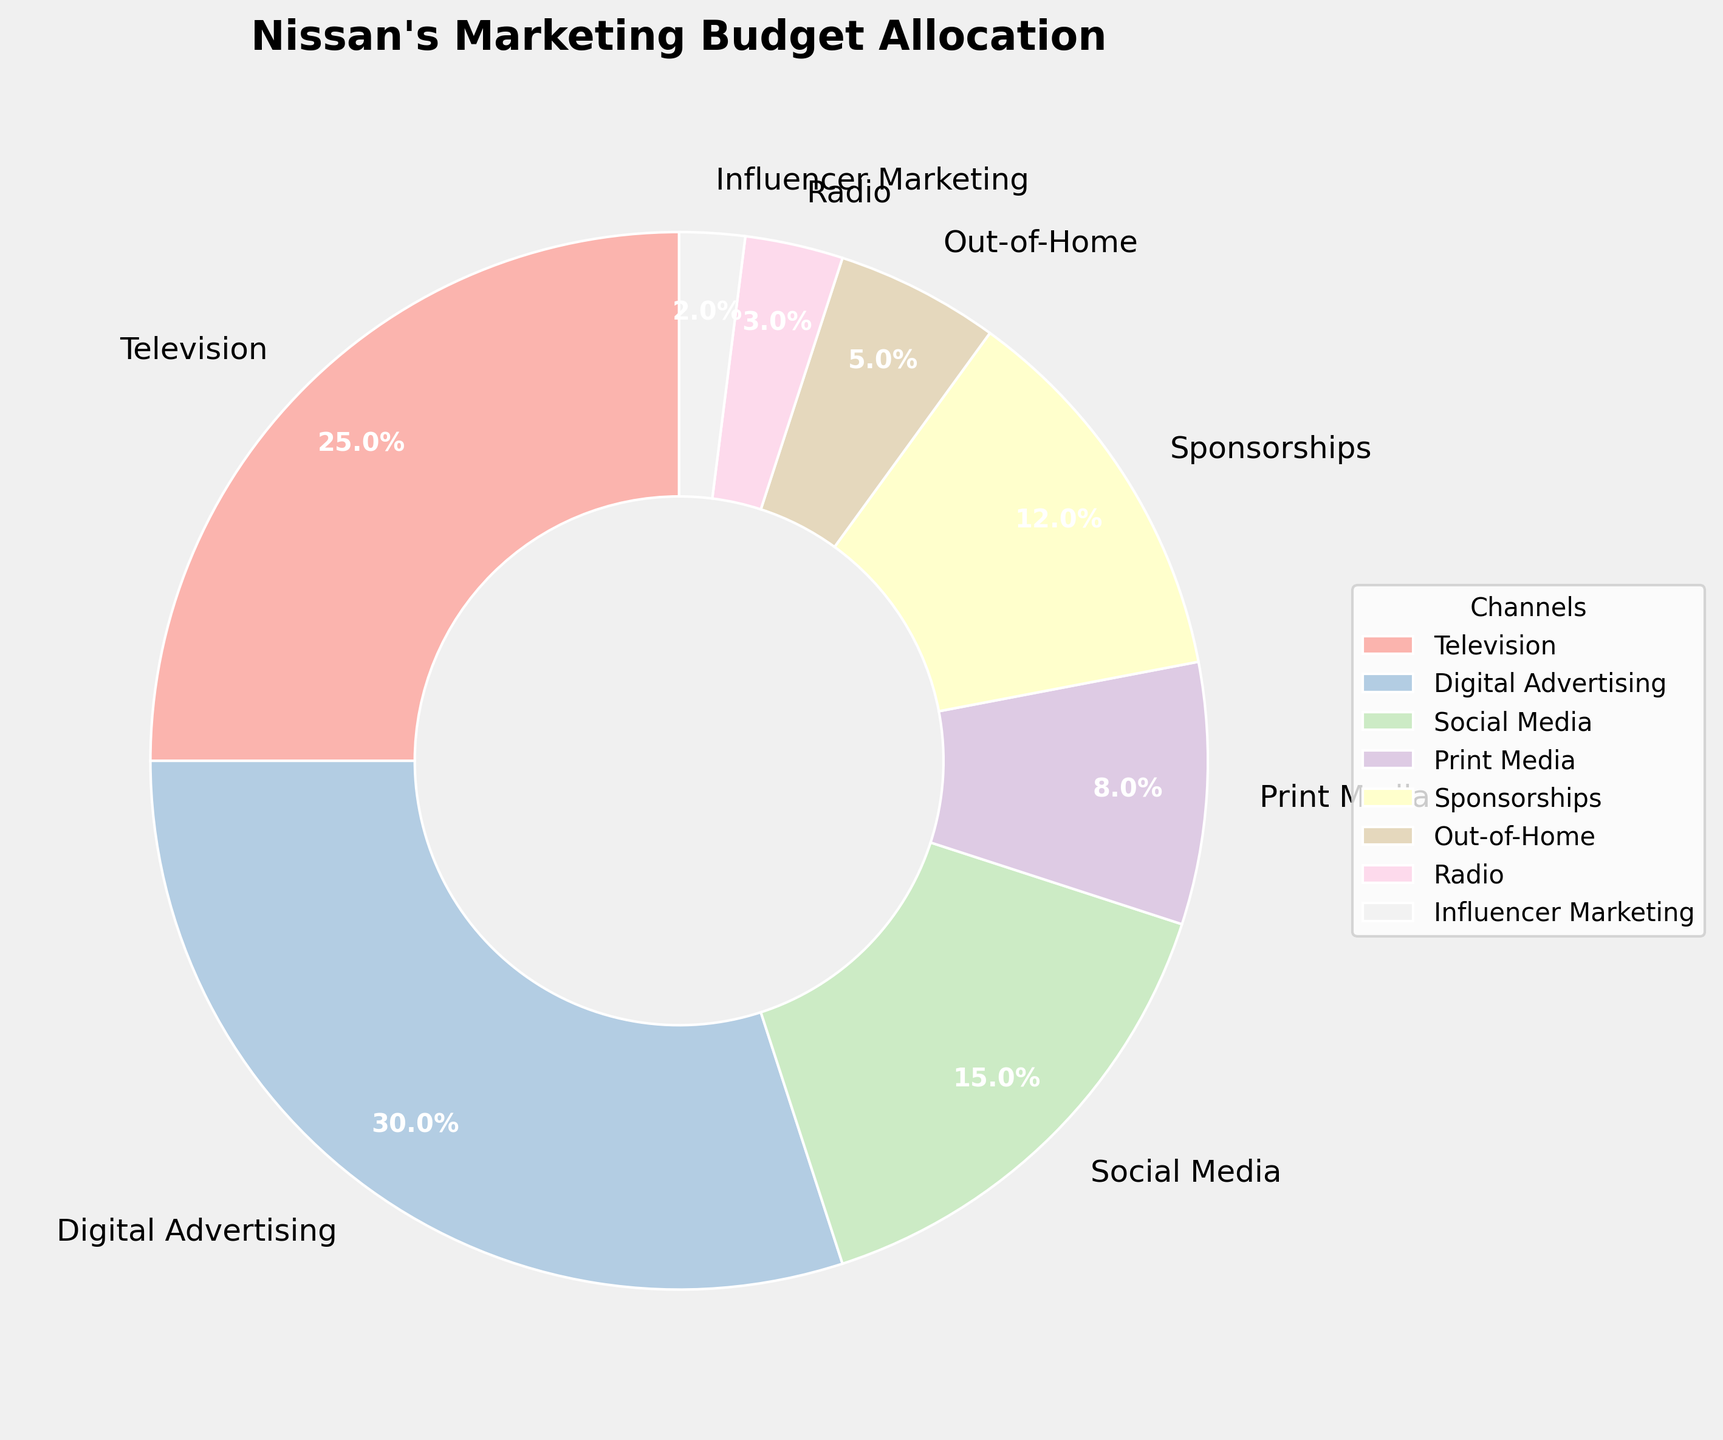Which channel has the highest allocation of Nissan's marketing budget? Look at the segment with the largest angle. It is labeled "Digital Advertising" with 30%.
Answer: Digital Advertising What percentage of the budget is allocated to social media and influencer marketing combined? Add the percentages of Social Media (15%) and Influencer Marketing (2%): 15% + 2% = 17%.
Answer: 17% Which channel has a smaller budget allocation: Radio or Out-of-Home? Compare the percentages directly. Radio is at 3%, and Out-of-Home is at 5%.
Answer: Radio Is the budget allocated to Television more than the combined budget for Sponsorships and Print Media? Calculate the sum of Sponsorships (12%) and Print Media (8%): 12% + 8% = 20%. Television is 25%, which is greater than 20%.
Answer: Yes What is the difference in budget allocation between the highest and the lowest channels? Subtract the smallest percentage (Influencer Marketing, 2%) from the largest percentage (Digital Advertising, 30%): 30% - 2% = 28%.
Answer: 28% Which color is used for the Print Media segment? Locate the "Print Media" label and identify its color on the pie chart. The color is pastel pink.
Answer: pastel pink What is the combined percentage for channels with a budget allocation of less than 10%? Add the percentages for Print Media (8%), Out-of-Home (5%), Radio (3%), and Influencer Marketing (2%): 8% + 5% + 3% + 2% = 18%.
Answer: 18% What channel has the third-largest budget allocation? List the percentages in descending order: 30% (Digital Advertising), 25% (Television), and 15% (Social Media). The third-largest is Social Media at 15%.
Answer: Social Media 